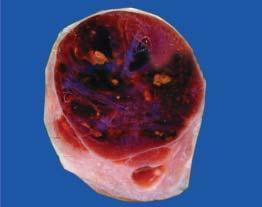does cut section show lobules of translucent gelatinous light brown parenchyma and areas of haemorrhage?
Answer the question using a single word or phrase. Yes 